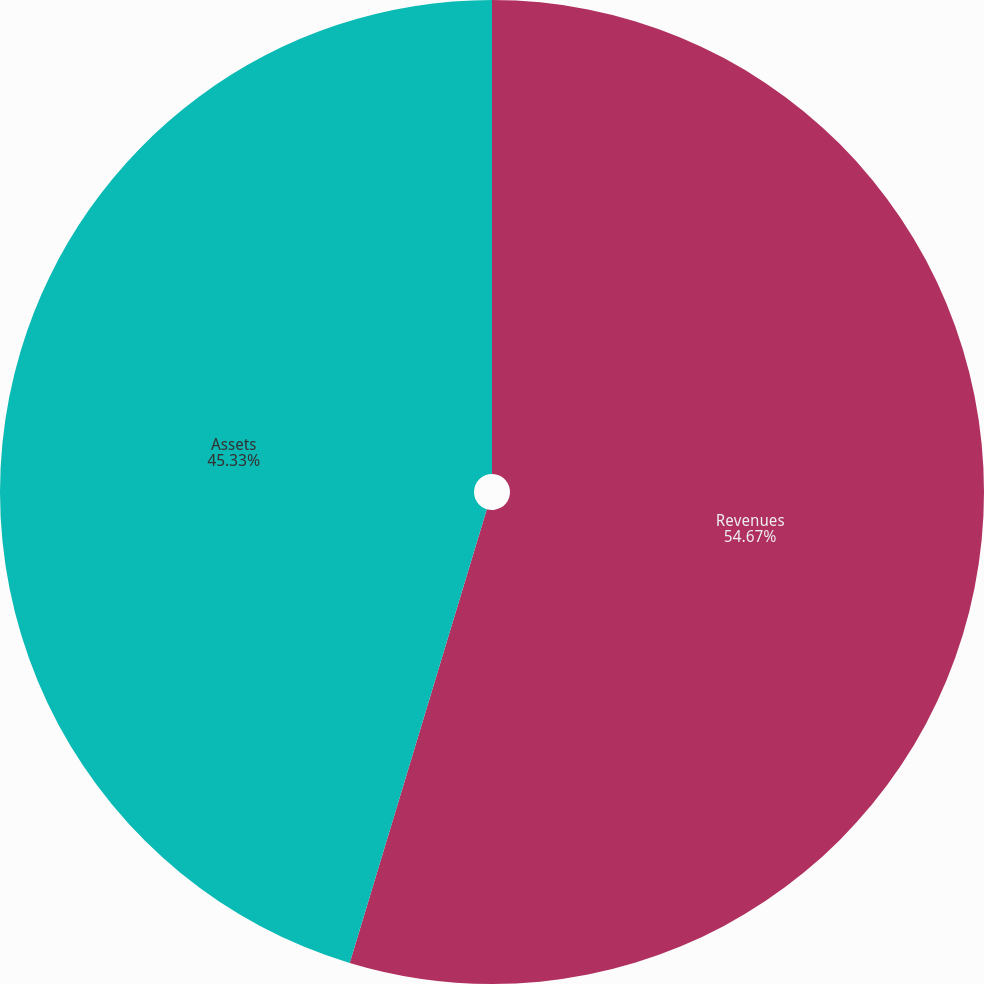Convert chart. <chart><loc_0><loc_0><loc_500><loc_500><pie_chart><fcel>Revenues<fcel>Assets<nl><fcel>54.67%<fcel>45.33%<nl></chart> 